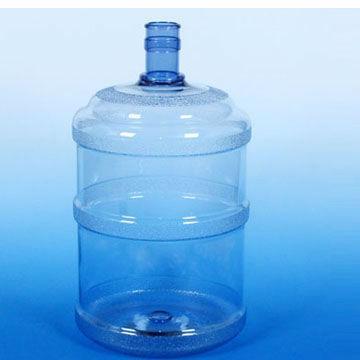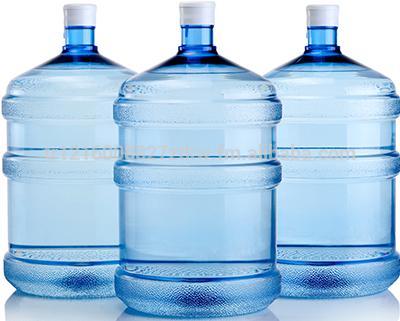The first image is the image on the left, the second image is the image on the right. Evaluate the accuracy of this statement regarding the images: "Each image contains a single upright blue-translucent water jug.". Is it true? Answer yes or no. No. The first image is the image on the left, the second image is the image on the right. Evaluate the accuracy of this statement regarding the images: "All images feature a single plastic jug.". Is it true? Answer yes or no. No. 